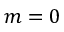<formula> <loc_0><loc_0><loc_500><loc_500>m = 0</formula> 